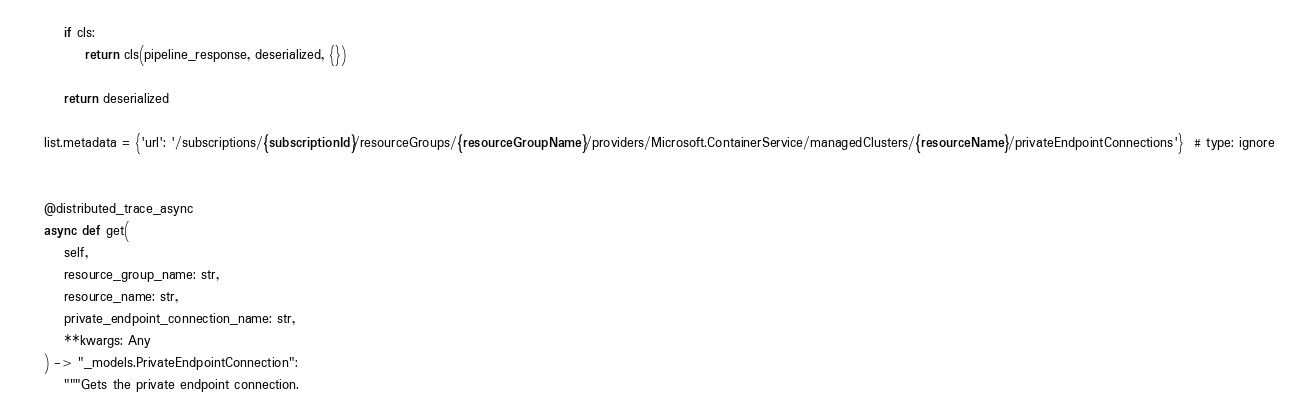<code> <loc_0><loc_0><loc_500><loc_500><_Python_>
        if cls:
            return cls(pipeline_response, deserialized, {})

        return deserialized

    list.metadata = {'url': '/subscriptions/{subscriptionId}/resourceGroups/{resourceGroupName}/providers/Microsoft.ContainerService/managedClusters/{resourceName}/privateEndpointConnections'}  # type: ignore


    @distributed_trace_async
    async def get(
        self,
        resource_group_name: str,
        resource_name: str,
        private_endpoint_connection_name: str,
        **kwargs: Any
    ) -> "_models.PrivateEndpointConnection":
        """Gets the private endpoint connection.
</code> 